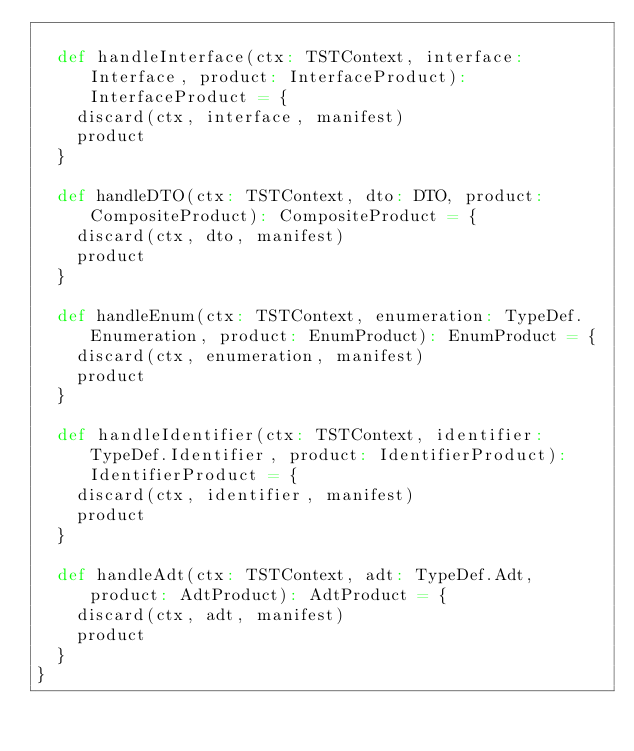Convert code to text. <code><loc_0><loc_0><loc_500><loc_500><_Scala_>
  def handleInterface(ctx: TSTContext, interface: Interface, product: InterfaceProduct): InterfaceProduct = {
    discard(ctx, interface, manifest)
    product
  }

  def handleDTO(ctx: TSTContext, dto: DTO, product: CompositeProduct): CompositeProduct = {
    discard(ctx, dto, manifest)
    product
  }

  def handleEnum(ctx: TSTContext, enumeration: TypeDef.Enumeration, product: EnumProduct): EnumProduct = {
    discard(ctx, enumeration, manifest)
    product
  }

  def handleIdentifier(ctx: TSTContext, identifier: TypeDef.Identifier, product: IdentifierProduct): IdentifierProduct = {
    discard(ctx, identifier, manifest)
    product
  }

  def handleAdt(ctx: TSTContext, adt: TypeDef.Adt, product: AdtProduct): AdtProduct = {
    discard(ctx, adt, manifest)
    product
  }
}
</code> 